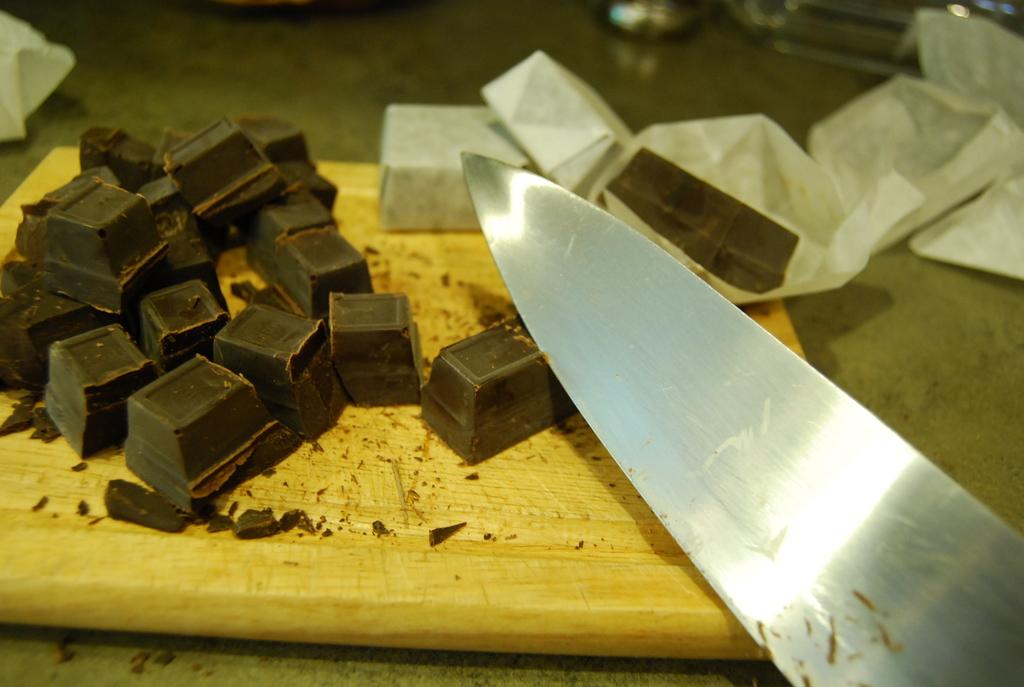What type of utensil can be seen in the image? There is a knife in the image. What else is present in the image besides the knife? There is a wrapper and chocolates in the image. Where are the chocolates located? The chocolates are on an object in the image. What can be seen behind the object where the chocolates are placed? There are items visible behind the object. What type of rings can be seen on the chocolates in the image? There are no rings present on the chocolates in the image. What type of wax is used to coat the chocolates in the image? There is no wax present on the chocolates in the image. 